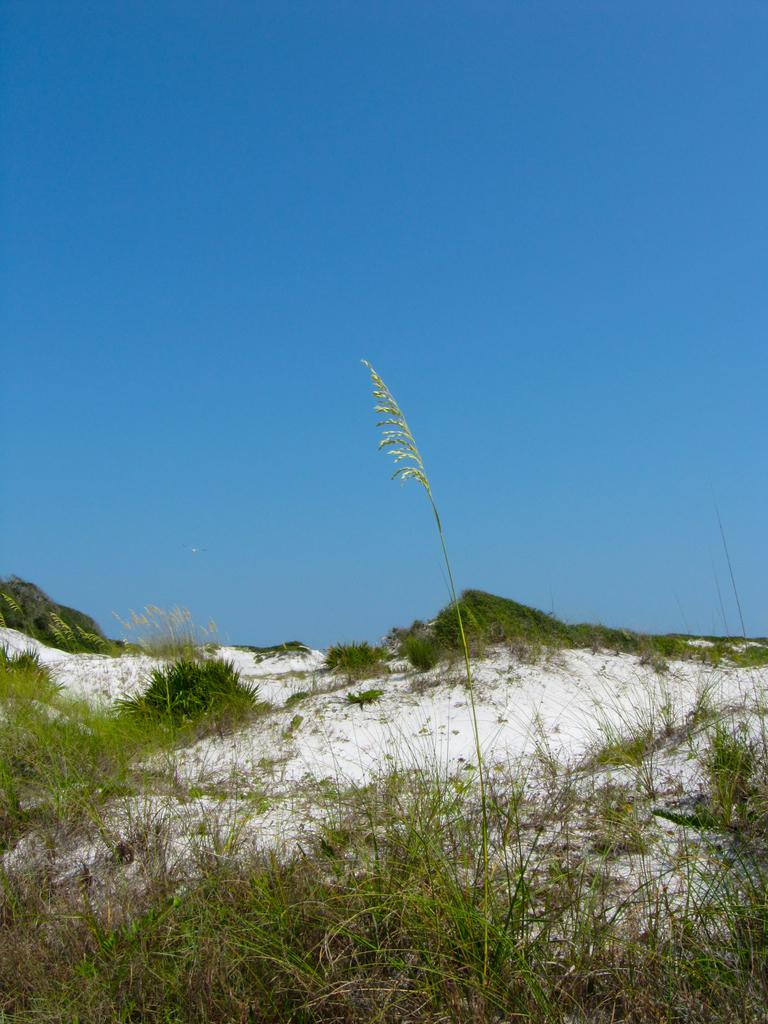What type of vegetation is present in the image? There is grass in the image. What weather condition is depicted in the image? There is snow in the image. What can be seen in the background of the image? The sky is visible in the background of the image. What is the color of the sky in the image? The color of the sky is blue. Where is the fireman's finger located in the image? There is no fireman or finger present in the image. What type of powder is visible on the grass in the image? There is no powder visible on the grass in the image. 